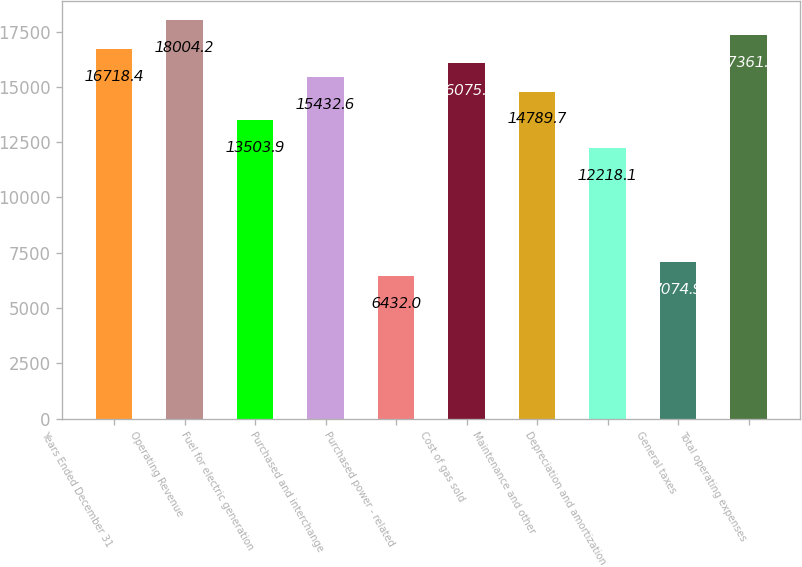Convert chart to OTSL. <chart><loc_0><loc_0><loc_500><loc_500><bar_chart><fcel>Years Ended December 31<fcel>Operating Revenue<fcel>Fuel for electric generation<fcel>Purchased and interchange<fcel>Purchased power - related<fcel>Cost of gas sold<fcel>Maintenance and other<fcel>Depreciation and amortization<fcel>General taxes<fcel>Total operating expenses<nl><fcel>16718.4<fcel>18004.2<fcel>13503.9<fcel>15432.6<fcel>6432<fcel>16075.5<fcel>14789.7<fcel>12218.1<fcel>7074.9<fcel>17361.3<nl></chart> 